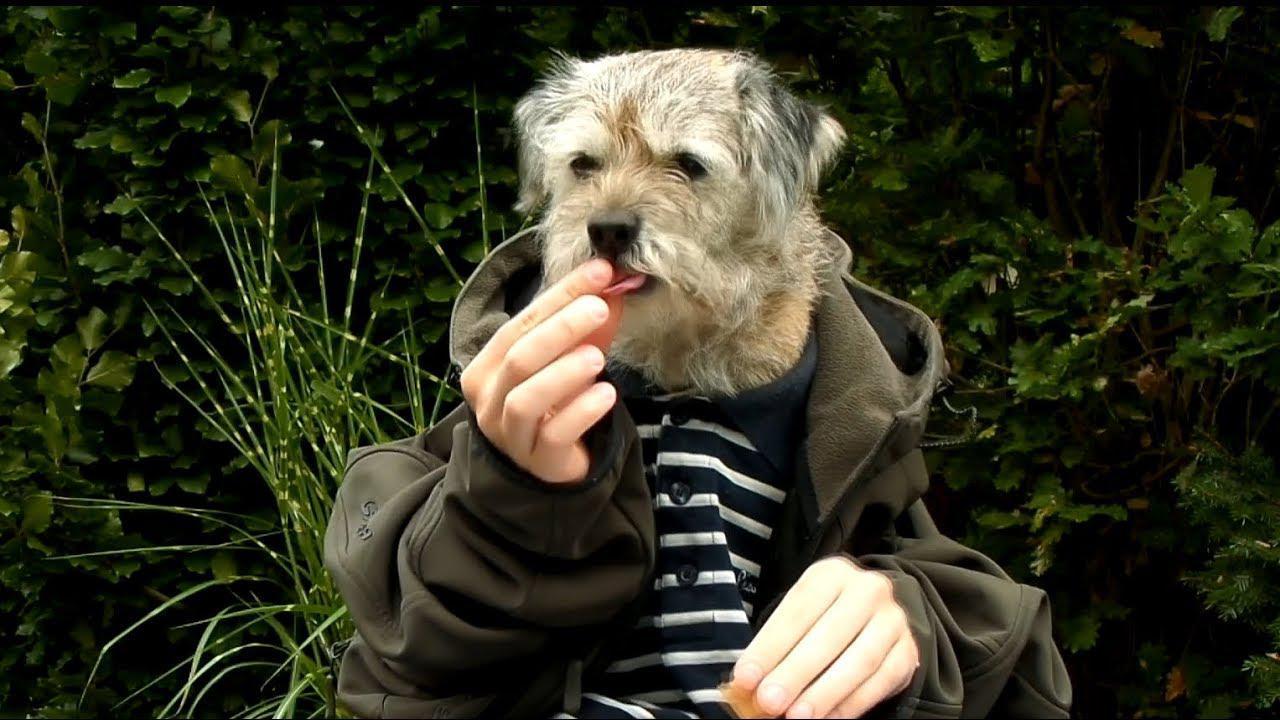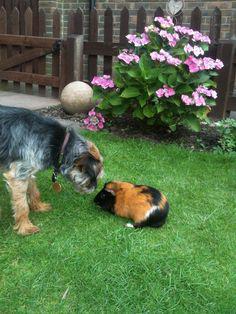The first image is the image on the left, the second image is the image on the right. For the images displayed, is the sentence "There are exactly two dogs and two guinea pigs." factually correct? Answer yes or no. No. The first image is the image on the left, the second image is the image on the right. Evaluate the accuracy of this statement regarding the images: "Each image shows one guinea pig to the left of one puppy, and the right image shows a guinea pig overlapping a sitting puppy.". Is it true? Answer yes or no. No. 